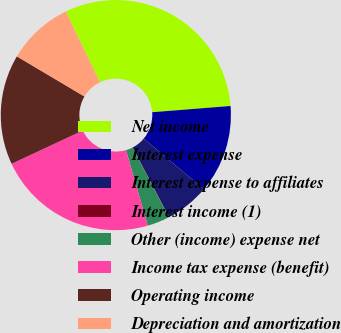Convert chart. <chart><loc_0><loc_0><loc_500><loc_500><pie_chart><fcel>Net income<fcel>Interest expense<fcel>Interest expense to affiliates<fcel>Interest income (1)<fcel>Other (income) expense net<fcel>Income tax expense (benefit)<fcel>Operating income<fcel>Depreciation and amortization<nl><fcel>30.91%<fcel>12.39%<fcel>6.22%<fcel>0.04%<fcel>3.13%<fcel>22.53%<fcel>15.48%<fcel>9.3%<nl></chart> 